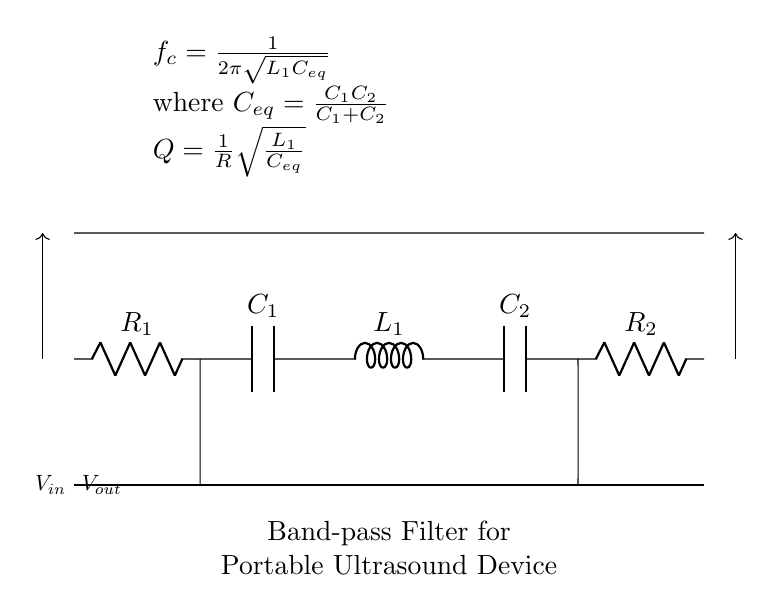What type of filter is depicted in the circuit? The circuit is a band-pass filter, which is indicated in the labeled section of the diagram.
Answer: band-pass filter What are the values of the resistors in the circuit? The circuit includes two resistors, R1 and R2. However, their specific numerical values are not shown in the diagram.
Answer: R1 and R2 What is the resonant frequency formula in this circuit? The formula for the resonant frequency is provided in the node above the circuit: f_c = 1/(2π√(L1C_eq)).
Answer: f_c = 1/(2π√(L1C_eq)) What does C_eq represent in this circuit? C_eq is the equivalent capacitance calculated using C1 and C2 in the formula provided, indicating it accounts for the contribution of both capacitors connected in parallel.
Answer: equivalent capacitance How is the quality factor defined in this band-pass filter? The quality factor Q is defined as Q = (1/R)√(L1/C_eq), illustrating the relationship between resistance, inductance, and capacitance.
Answer: Q = (1/R)√(L1/C_eq) What are the input and output voltages in this circuit? The input voltage (Vin) enters from the left, and the output voltage (Vout) exits on the right, but their numerical values are not provided in the diagram.
Answer: Vin and Vout Where can we find the inductance in the circuit? The inductance is shown as L1 located in the series arrangement of the components of the circuit diagram.
Answer: L1 